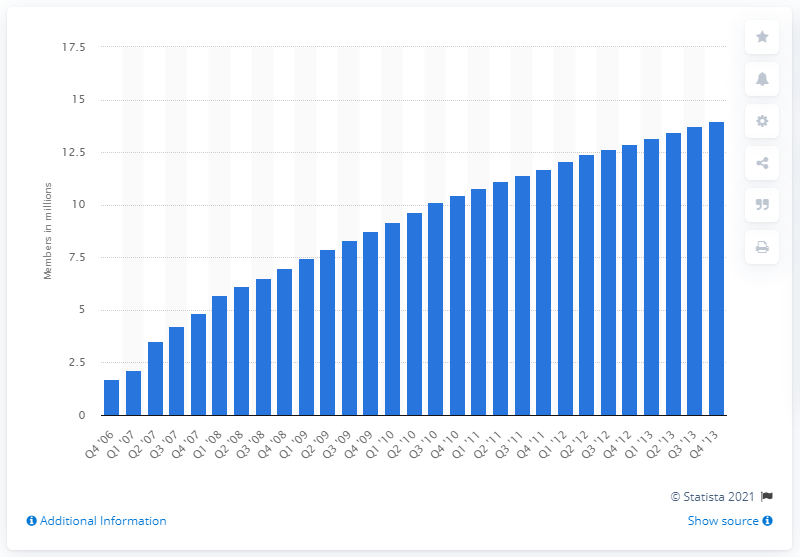Outline some significant characteristics in this image. As of the second quarter of 2013, the business professionals social network had 13,460 members. 